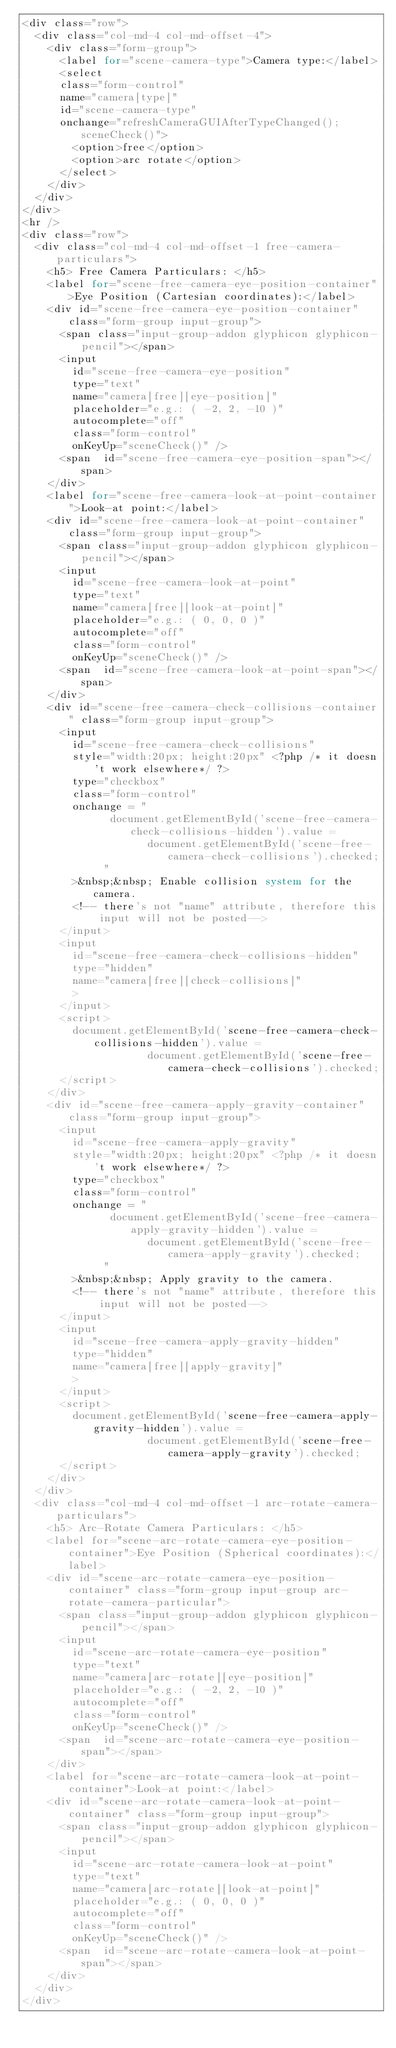<code> <loc_0><loc_0><loc_500><loc_500><_PHP_><div class="row">
	<div class="col-md-4 col-md-offset-4">
		<div class="form-group">
			<label for="scene-camera-type">Camera type:</label>
			<select 
			class="form-control" 
			name="camera[type]" 
			id="scene-camera-type" 
			onchange="refreshCameraGUIAfterTypeChanged(); sceneCheck()">
				<option>free</option>
				<option>arc rotate</option>
			</select>
		</div>
	</div>
</div>
<hr />
<div class="row">
	<div class="col-md-4 col-md-offset-1 free-camera-particulars">
		<h5> Free Camera Particulars: </h5>
		<label for="scene-free-camera-eye-position-container">Eye Position (Cartesian coordinates):</label>
		<div id="scene-free-camera-eye-position-container" class="form-group input-group">
			<span class="input-group-addon glyphicon glyphicon-pencil"></span>
			<input 
				id="scene-free-camera-eye-position" 
				type="text" 
				name="camera[free][eye-position]" 
				placeholder="e.g.: ( -2, 2, -10 )" 
				autocomplete="off" 
				class="form-control"  
				onKeyUp="sceneCheck()" />
			<span  id="scene-free-camera-eye-position-span"></span>
		</div>
		<label for="scene-free-camera-look-at-point-container">Look-at point:</label>
		<div id="scene-free-camera-look-at-point-container" class="form-group input-group">
			<span class="input-group-addon glyphicon glyphicon-pencil"></span>
			<input 
				id="scene-free-camera-look-at-point" 
				type="text" 
				name="camera[free][look-at-point]" 
				placeholder="e.g.: ( 0, 0, 0 )" 
				autocomplete="off" 
				class="form-control"  
				onKeyUp="sceneCheck()" />
			<span  id="scene-free-camera-look-at-point-span"></span>
		</div>
		<div id="scene-free-camera-check-collisions-container" class="form-group input-group">
			<input 
				id="scene-free-camera-check-collisions"
				style="width:20px; height:20px" <?php /* it doesn't work elsewhere*/ ?>
				type="checkbox" 
				class="form-control" 
				onchange = "
					   	document.getElementById('scene-free-camera-check-collisions-hidden').value = 
										document.getElementById('scene-free-camera-check-collisions').checked;
					   " 
				>&nbsp;&nbsp; Enable collision system for the camera.
				<!-- there's not "name" attribute, therefore this input will not be posted-->
			</input>
			<input 
				id="scene-free-camera-check-collisions-hidden" 
				type="hidden" 
				name="camera[free][check-collisions]" 
				>
			</input>
			<script>
				document.getElementById('scene-free-camera-check-collisions-hidden').value = 
										document.getElementById('scene-free-camera-check-collisions').checked;
			</script>
		</div>
		<div id="scene-free-camera-apply-gravity-container" class="form-group input-group">
			<input 
				id="scene-free-camera-apply-gravity"
				style="width:20px; height:20px" <?php /* it doesn't work elsewhere*/ ?>
				type="checkbox" 
				class="form-control" 
				onchange = "
					   	document.getElementById('scene-free-camera-apply-gravity-hidden').value = 
										document.getElementById('scene-free-camera-apply-gravity').checked;
					   " 
				>&nbsp;&nbsp; Apply gravity to the camera.
				<!-- there's not "name" attribute, therefore this input will not be posted-->
			</input>
			<input 
				id="scene-free-camera-apply-gravity-hidden" 
				type="hidden" 
				name="camera[free][apply-gravity]" 
				>
			</input>
			<script>
				document.getElementById('scene-free-camera-apply-gravity-hidden').value = 
										document.getElementById('scene-free-camera-apply-gravity').checked;
			</script>
		</div>
	</div>
	<div class="col-md-4 col-md-offset-1 arc-rotate-camera-particulars">
		<h5> Arc-Rotate Camera Particulars: </h5>
		<label for="scene-arc-rotate-camera-eye-position-container">Eye Position (Spherical coordinates):</label>
		<div id="scene-arc-rotate-camera-eye-position-container" class="form-group input-group arc-rotate-camera-particular">
			<span class="input-group-addon glyphicon glyphicon-pencil"></span>
			<input 
				id="scene-arc-rotate-camera-eye-position" 
				type="text" 
				name="camera[arc-rotate][eye-position]" 
				placeholder="e.g.: ( -2, 2, -10 )"
				autocomplete="off" 
				class="form-control"  
				onKeyUp="sceneCheck()" />
			<span  id="scene-arc-rotate-camera-eye-position-span"></span>
		</div>
		<label for="scene-arc-rotate-camera-look-at-point-container">Look-at point:</label>
		<div id="scene-arc-rotate-camera-look-at-point-container" class="form-group input-group">
			<span class="input-group-addon glyphicon glyphicon-pencil"></span>
			<input 
				id="scene-arc-rotate-camera-look-at-point" 
				type="text" 
				name="camera[arc-rotate][look-at-point]" 
				placeholder="e.g.: ( 0, 0, 0 )" 
				autocomplete="off" 
				class="form-control"  
				onKeyUp="sceneCheck()" />
			<span  id="scene-arc-rotate-camera-look-at-point-span"></span>
		</div>
	</div>
</div>

</code> 